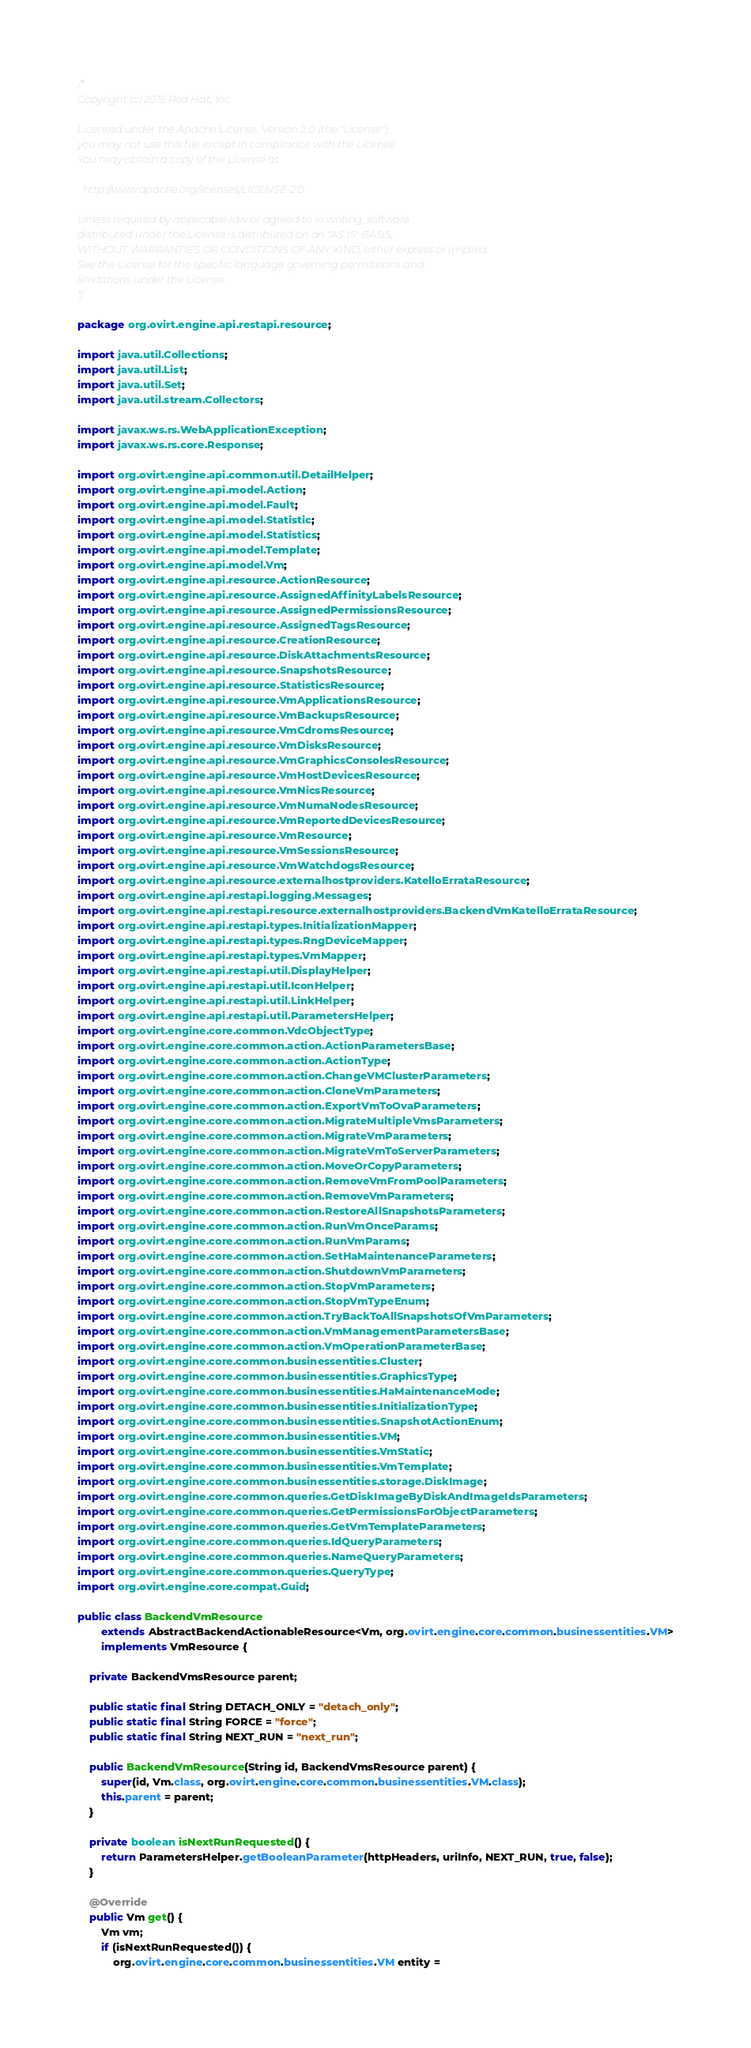<code> <loc_0><loc_0><loc_500><loc_500><_Java_>/*
Copyright (c) 2015 Red Hat, Inc.

Licensed under the Apache License, Version 2.0 (the "License");
you may not use this file except in compliance with the License.
You may obtain a copy of the License at

  http://www.apache.org/licenses/LICENSE-2.0

Unless required by applicable law or agreed to in writing, software
distributed under the License is distributed on an "AS IS" BASIS,
WITHOUT WARRANTIES OR CONDITIONS OF ANY KIND, either express or implied.
See the License for the specific language governing permissions and
limitations under the License.
*/

package org.ovirt.engine.api.restapi.resource;

import java.util.Collections;
import java.util.List;
import java.util.Set;
import java.util.stream.Collectors;

import javax.ws.rs.WebApplicationException;
import javax.ws.rs.core.Response;

import org.ovirt.engine.api.common.util.DetailHelper;
import org.ovirt.engine.api.model.Action;
import org.ovirt.engine.api.model.Fault;
import org.ovirt.engine.api.model.Statistic;
import org.ovirt.engine.api.model.Statistics;
import org.ovirt.engine.api.model.Template;
import org.ovirt.engine.api.model.Vm;
import org.ovirt.engine.api.resource.ActionResource;
import org.ovirt.engine.api.resource.AssignedAffinityLabelsResource;
import org.ovirt.engine.api.resource.AssignedPermissionsResource;
import org.ovirt.engine.api.resource.AssignedTagsResource;
import org.ovirt.engine.api.resource.CreationResource;
import org.ovirt.engine.api.resource.DiskAttachmentsResource;
import org.ovirt.engine.api.resource.SnapshotsResource;
import org.ovirt.engine.api.resource.StatisticsResource;
import org.ovirt.engine.api.resource.VmApplicationsResource;
import org.ovirt.engine.api.resource.VmBackupsResource;
import org.ovirt.engine.api.resource.VmCdromsResource;
import org.ovirt.engine.api.resource.VmDisksResource;
import org.ovirt.engine.api.resource.VmGraphicsConsolesResource;
import org.ovirt.engine.api.resource.VmHostDevicesResource;
import org.ovirt.engine.api.resource.VmNicsResource;
import org.ovirt.engine.api.resource.VmNumaNodesResource;
import org.ovirt.engine.api.resource.VmReportedDevicesResource;
import org.ovirt.engine.api.resource.VmResource;
import org.ovirt.engine.api.resource.VmSessionsResource;
import org.ovirt.engine.api.resource.VmWatchdogsResource;
import org.ovirt.engine.api.resource.externalhostproviders.KatelloErrataResource;
import org.ovirt.engine.api.restapi.logging.Messages;
import org.ovirt.engine.api.restapi.resource.externalhostproviders.BackendVmKatelloErrataResource;
import org.ovirt.engine.api.restapi.types.InitializationMapper;
import org.ovirt.engine.api.restapi.types.RngDeviceMapper;
import org.ovirt.engine.api.restapi.types.VmMapper;
import org.ovirt.engine.api.restapi.util.DisplayHelper;
import org.ovirt.engine.api.restapi.util.IconHelper;
import org.ovirt.engine.api.restapi.util.LinkHelper;
import org.ovirt.engine.api.restapi.util.ParametersHelper;
import org.ovirt.engine.core.common.VdcObjectType;
import org.ovirt.engine.core.common.action.ActionParametersBase;
import org.ovirt.engine.core.common.action.ActionType;
import org.ovirt.engine.core.common.action.ChangeVMClusterParameters;
import org.ovirt.engine.core.common.action.CloneVmParameters;
import org.ovirt.engine.core.common.action.ExportVmToOvaParameters;
import org.ovirt.engine.core.common.action.MigrateMultipleVmsParameters;
import org.ovirt.engine.core.common.action.MigrateVmParameters;
import org.ovirt.engine.core.common.action.MigrateVmToServerParameters;
import org.ovirt.engine.core.common.action.MoveOrCopyParameters;
import org.ovirt.engine.core.common.action.RemoveVmFromPoolParameters;
import org.ovirt.engine.core.common.action.RemoveVmParameters;
import org.ovirt.engine.core.common.action.RestoreAllSnapshotsParameters;
import org.ovirt.engine.core.common.action.RunVmOnceParams;
import org.ovirt.engine.core.common.action.RunVmParams;
import org.ovirt.engine.core.common.action.SetHaMaintenanceParameters;
import org.ovirt.engine.core.common.action.ShutdownVmParameters;
import org.ovirt.engine.core.common.action.StopVmParameters;
import org.ovirt.engine.core.common.action.StopVmTypeEnum;
import org.ovirt.engine.core.common.action.TryBackToAllSnapshotsOfVmParameters;
import org.ovirt.engine.core.common.action.VmManagementParametersBase;
import org.ovirt.engine.core.common.action.VmOperationParameterBase;
import org.ovirt.engine.core.common.businessentities.Cluster;
import org.ovirt.engine.core.common.businessentities.GraphicsType;
import org.ovirt.engine.core.common.businessentities.HaMaintenanceMode;
import org.ovirt.engine.core.common.businessentities.InitializationType;
import org.ovirt.engine.core.common.businessentities.SnapshotActionEnum;
import org.ovirt.engine.core.common.businessentities.VM;
import org.ovirt.engine.core.common.businessentities.VmStatic;
import org.ovirt.engine.core.common.businessentities.VmTemplate;
import org.ovirt.engine.core.common.businessentities.storage.DiskImage;
import org.ovirt.engine.core.common.queries.GetDiskImageByDiskAndImageIdsParameters;
import org.ovirt.engine.core.common.queries.GetPermissionsForObjectParameters;
import org.ovirt.engine.core.common.queries.GetVmTemplateParameters;
import org.ovirt.engine.core.common.queries.IdQueryParameters;
import org.ovirt.engine.core.common.queries.NameQueryParameters;
import org.ovirt.engine.core.common.queries.QueryType;
import org.ovirt.engine.core.compat.Guid;

public class BackendVmResource
        extends AbstractBackendActionableResource<Vm, org.ovirt.engine.core.common.businessentities.VM>
        implements VmResource {

    private BackendVmsResource parent;

    public static final String DETACH_ONLY = "detach_only";
    public static final String FORCE = "force";
    public static final String NEXT_RUN = "next_run";

    public BackendVmResource(String id, BackendVmsResource parent) {
        super(id, Vm.class, org.ovirt.engine.core.common.businessentities.VM.class);
        this.parent = parent;
    }

    private boolean isNextRunRequested() {
        return ParametersHelper.getBooleanParameter(httpHeaders, uriInfo, NEXT_RUN, true, false);
    }

    @Override
    public Vm get() {
        Vm vm;
        if (isNextRunRequested()) {
            org.ovirt.engine.core.common.businessentities.VM entity =</code> 